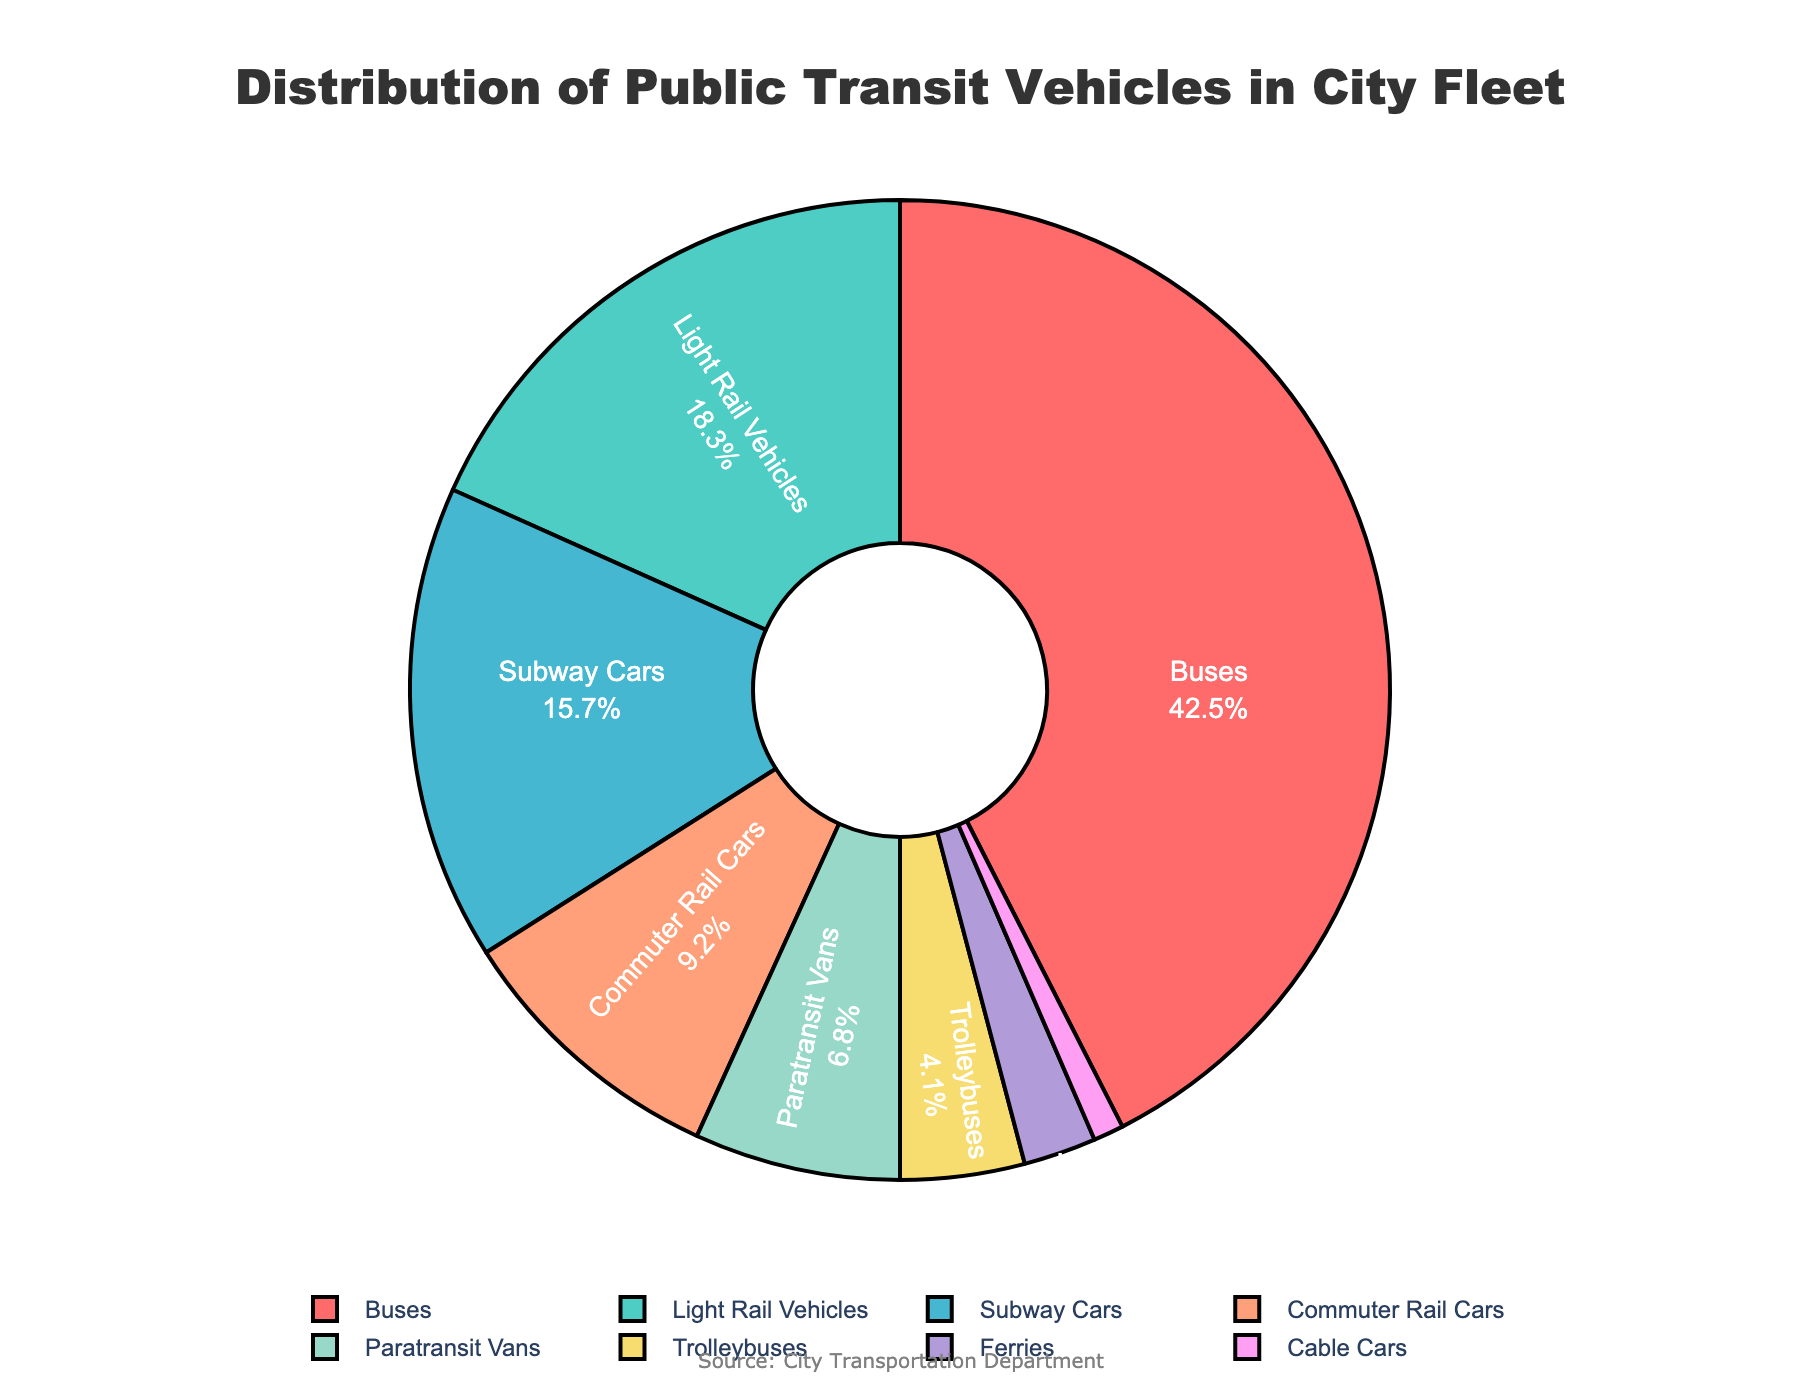Which type of vehicle has the highest percentage in the city's fleet? Look at the sectors of the pie chart and identify the one with the largest area. The largest sector represents the vehicle with the highest percentage.
Answer: Buses What is the combined percentage of Buses and Light Rail Vehicles? First, note the individual percentages of Buses and Light Rail Vehicles: 42.5% and 18.3%, respectively. Add these two values together: 42.5 + 18.3 = 60.8%.
Answer: 60.8% Which vehicle has a smaller percentage representation in the fleet, Commuter Rail Cars or Paratransit Vans? Compare the individual percentages for Commuter Rail Cars (9.2%) and Paratransit Vans (6.8%). Since 6.8% is smaller than 9.2%, Paratransit Vans have a smaller percentage representation.
Answer: Paratransit Vans How much percentage more do Subway Cars have compared to Ferries? Identify the percentages for Subway Cars (15.7%) and Ferries (2.4%). Subtract the smaller percentage from the larger: 15.7 - 2.4 = 13.3%.
Answer: 13.3% What's the total percentage share of vehicles that are not on rails or tracks (sum of Buses, Paratransit Vans, Trolleybuses, and Ferries)? Add the percentages for Buses (42.5%), Paratransit Vans (6.8%), Trolleybuses (4.1%), and Ferries (2.4%): 42.5 + 6.8 + 4.1 + 2.4 = 55.8%.
Answer: 55.8% Are Light Rail Vehicles or Subway Cars more prevalent in the city's fleet? Compare the percentages for Light Rail Vehicles (18.3%) and Subway Cars (15.7%). Since 18.3% is greater than 15.7%, Light Rail Vehicles are more prevalent.
Answer: Light Rail Vehicles What's the sum of the percentages for vehicles with less than a 5% share each? Identify the vehicles with less than 5%: Trolleybuses (4.1%), Ferries (2.4%), and Cable Cars (1.0%). Add these percentages: 4.1 + 2.4 + 1.0 = 7.5%.
Answer: 7.5% Which color represents the Cable Cars in the pie chart? Look for the smallest segment in the pie chart, representing 1.0%, and identify its color. Based on the provided colors list, Cable Cars should be represented by the pinkish color visually depicted in the chart.
Answer: Pinkish What is the percentage representation of vehicles that run on tracks (sum of Light Rail Vehicles, Subway Cars, Commuter Rail Cars, and Cable Cars)? Add the percentages of Light Rail Vehicles (18.3%), Subway Cars (15.7%), Commuter Rail Cars (9.2%), and Cable Cars (1.0%): 18.3 + 15.7 + 9.2 + 1.0 = 44.2%.
Answer: 44.2% If the percentage of Buses were to decrease by 10%, which vehicle type would then have the highest percentage? Subtract 10% from the percentage of Buses: 42.5 - 10 = 32.5%. Compare this with the other vehicles' percentages: the next highest is Light Rail Vehicles at 18.3%. Since 32.5% is still higher than 18.3%, Buses would continue to have the highest percentage even with a 10% decrease.
Answer: Buses 